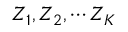<formula> <loc_0><loc_0><loc_500><loc_500>Z _ { 1 } , Z _ { 2 } , \cdots Z _ { K }</formula> 